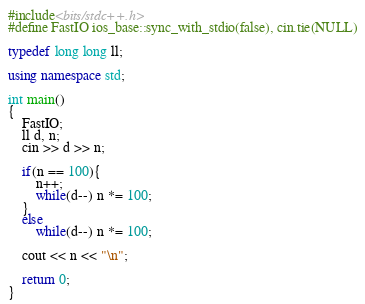<code> <loc_0><loc_0><loc_500><loc_500><_C++_>#include<bits/stdc++.h>
#define FastIO ios_base::sync_with_stdio(false), cin.tie(NULL)

typedef long long ll;

using namespace std;

int main()
{
	FastIO;
	ll d, n;
	cin >> d >> n;

	if(n == 100){
		n++;
		while(d--) n *= 100;
	}
	else
		while(d--) n *= 100;

	cout << n << "\n";
	
	return 0;
}</code> 